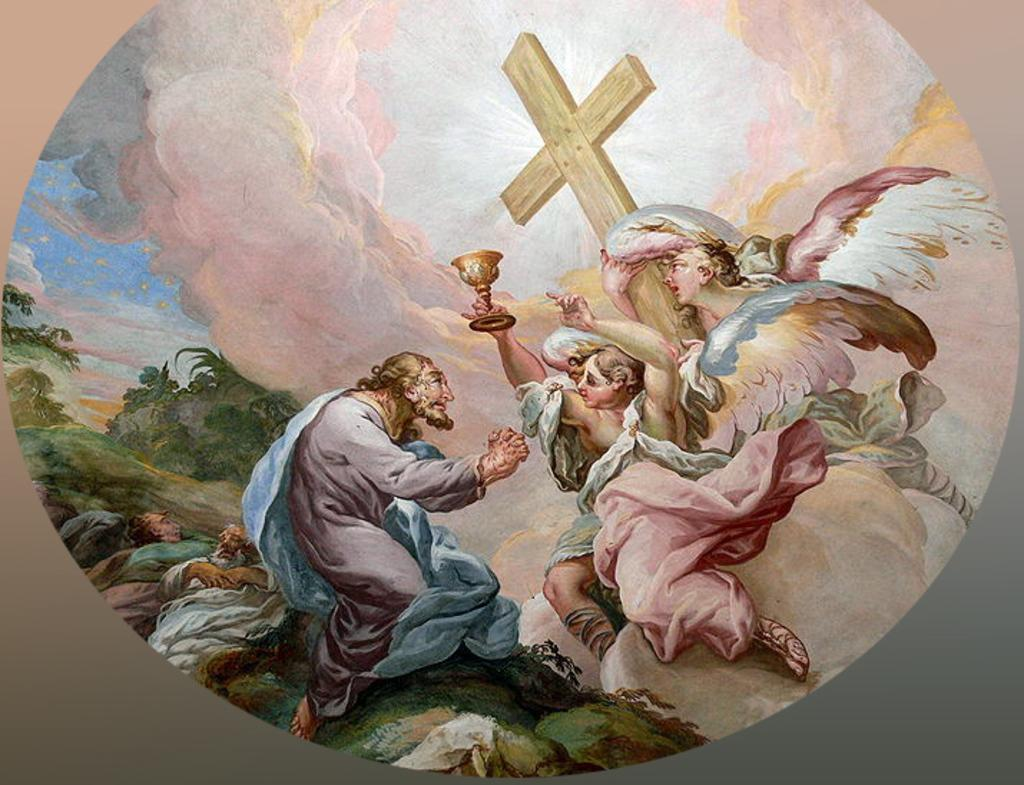What type of artwork is depicted in the image? The image is a painting on a wall. What subjects are included in the painting? There are people depicted in the painting. What objects are the people holding in the painting? One person is holding a cross, and another is holding a lamp. What type of landscape can be seen in the background of the painting? There are trees, rocks, and the sky visible in the background of the painting. What country is depicted in the painting? The painting does not depict a specific country; it is a scene with people, a cross, a lamp, trees, rocks, and the sky. How many boys are present in the painting? There is no mention of boys in the painting; the subjects are people holding a cross and a lamp. 